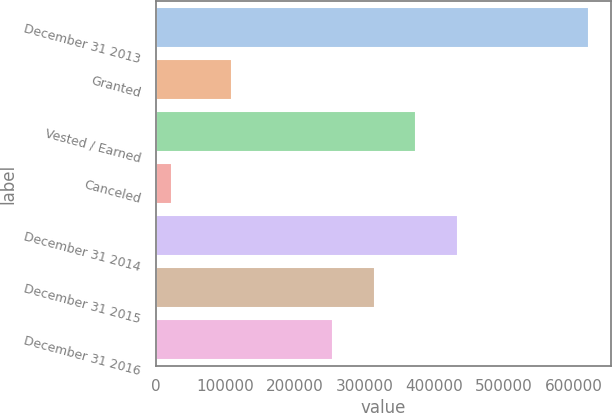<chart> <loc_0><loc_0><loc_500><loc_500><bar_chart><fcel>December 31 2013<fcel>Granted<fcel>Vested / Earned<fcel>Canceled<fcel>December 31 2014<fcel>December 31 2015<fcel>December 31 2016<nl><fcel>622021<fcel>109665<fcel>374034<fcel>23785<fcel>433858<fcel>314211<fcel>254387<nl></chart> 